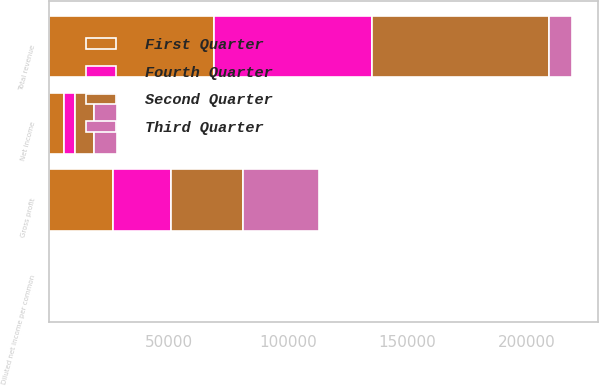<chart> <loc_0><loc_0><loc_500><loc_500><stacked_bar_chart><ecel><fcel>Total revenue<fcel>Gross profit<fcel>Net income<fcel>Diluted net income per common<nl><fcel>Fourth Quarter<fcel>66176<fcel>24208<fcel>4574<fcel>0.11<nl><fcel>First Quarter<fcel>69237<fcel>26773<fcel>6048<fcel>0.13<nl><fcel>Second Quarter<fcel>74053<fcel>30090<fcel>8158<fcel>0.18<nl><fcel>Third Quarter<fcel>9476<fcel>31953<fcel>9476<fcel>0.2<nl></chart> 